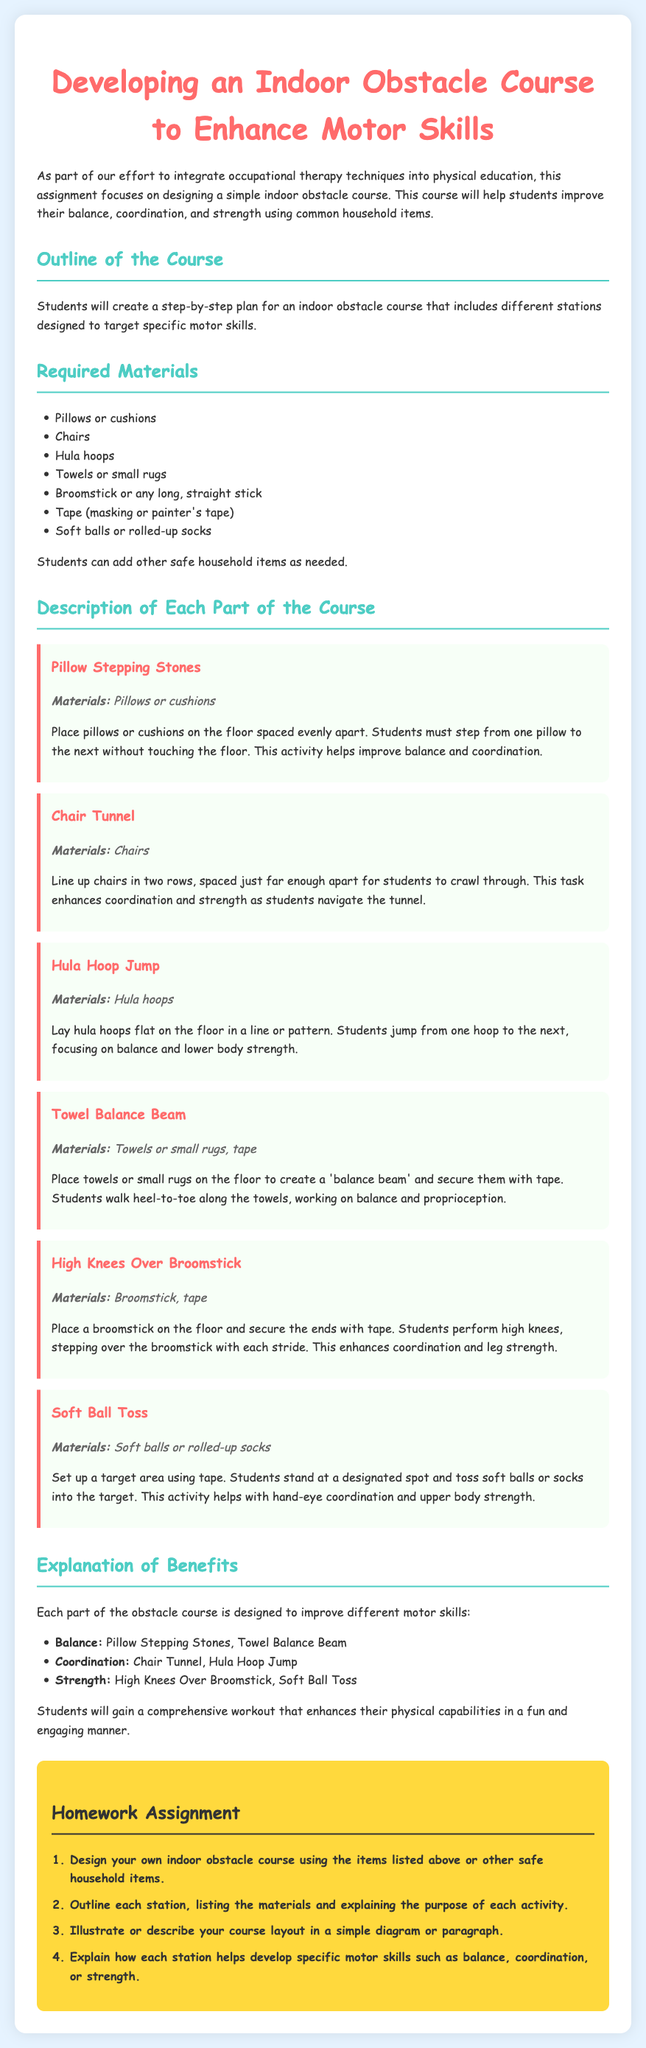What is the title of the homework assignment? The title is prominently displayed at the top of the document as the heading.
Answer: Developing an Indoor Obstacle Course to Enhance Motor Skills What material is used for the Pillow Stepping Stones? The document states the materials required for each part of the course listed under each obstacle description.
Answer: Pillows or cushions How many total parts are outlined for the obstacle course? The document presents various parts, and the description for each is found under the "Description of Each Part of the Course" section.
Answer: Six What motor skill does the High Knees Over Broomstick help improve? Each section specifies the motor skills targeted by the activities, including strength enhancement through certain tasks.
Answer: Coordination What household item is suggested for creating a balance beam? The document indicates which items to use for each course segment, specifically for the balance aspect.
Answer: Towels or small rugs How many steps are in the homework assignment? The homework section lists the steps, and the numbering indicates the total provided for completion.
Answer: Four Which obstacle involves throwing soft balls? The title of the section indicates the activity focused on this particular skill.
Answer: Soft Ball Toss What color is the homework assignment background? The visual design elements of the document, such as background color, are mentioned in the style section.
Answer: Yellow 